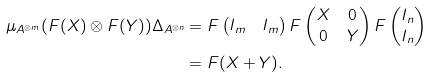<formula> <loc_0><loc_0><loc_500><loc_500>\mu _ { A ^ { \otimes m } } ( F ( X ) \otimes F ( Y ) ) \Delta _ { A ^ { \otimes n } } & = F \begin{pmatrix} I _ { m } & I _ { m } \end{pmatrix} F \begin{pmatrix} X & 0 \\ 0 & Y \end{pmatrix} F \begin{pmatrix} I _ { n } \\ I _ { n } \end{pmatrix} \\ & = F ( X + Y ) .</formula> 